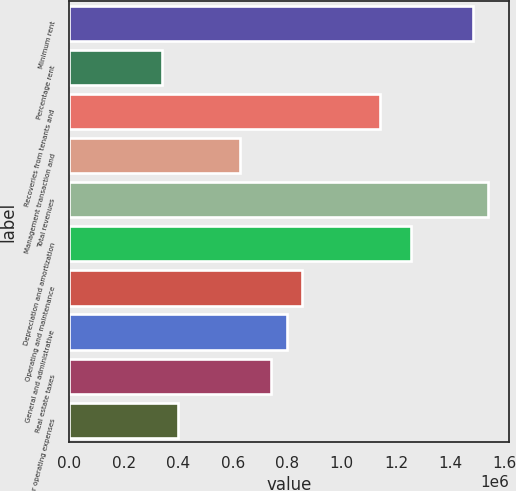<chart> <loc_0><loc_0><loc_500><loc_500><bar_chart><fcel>Minimum rent<fcel>Percentage rent<fcel>Recoveries from tenants and<fcel>Management transaction and<fcel>Total revenues<fcel>Depreciation and amortization<fcel>Operating and maintenance<fcel>General and administrative<fcel>Real estate taxes<fcel>Other operating expenses<nl><fcel>1.48138e+06<fcel>341858<fcel>1.13952e+06<fcel>626739<fcel>1.53836e+06<fcel>1.25348e+06<fcel>854644<fcel>797668<fcel>740691<fcel>398834<nl></chart> 